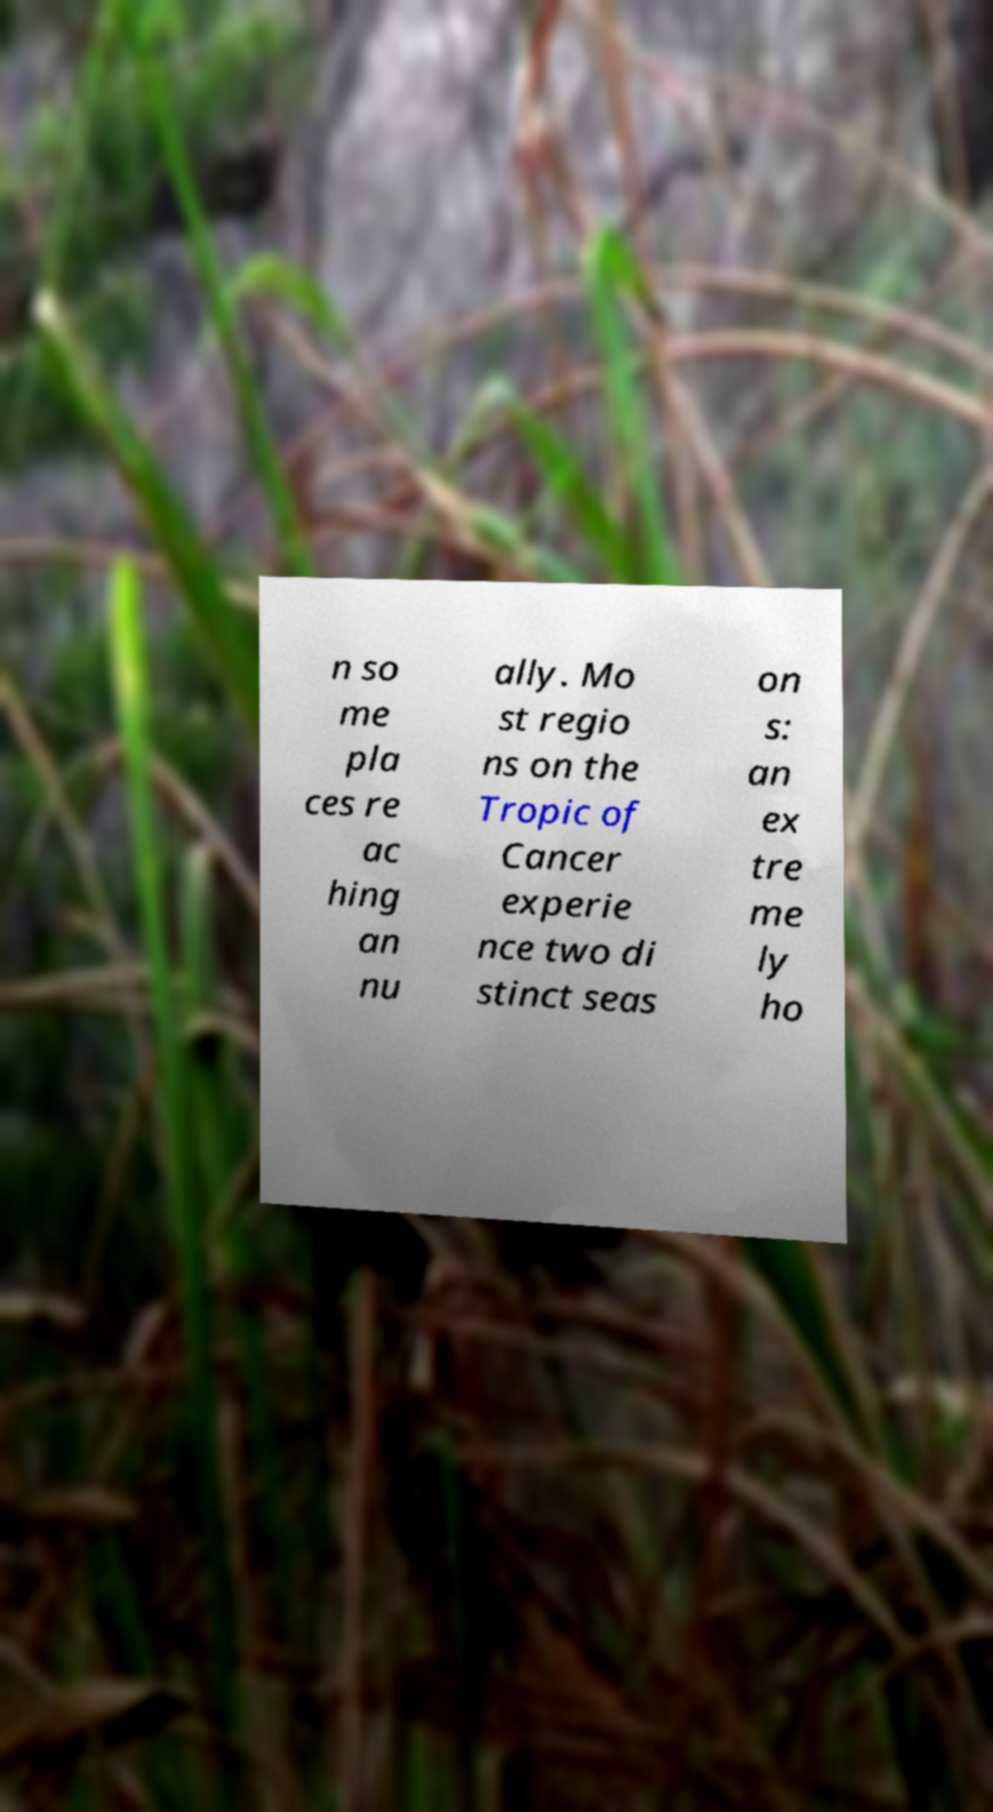Could you assist in decoding the text presented in this image and type it out clearly? n so me pla ces re ac hing an nu ally. Mo st regio ns on the Tropic of Cancer experie nce two di stinct seas on s: an ex tre me ly ho 